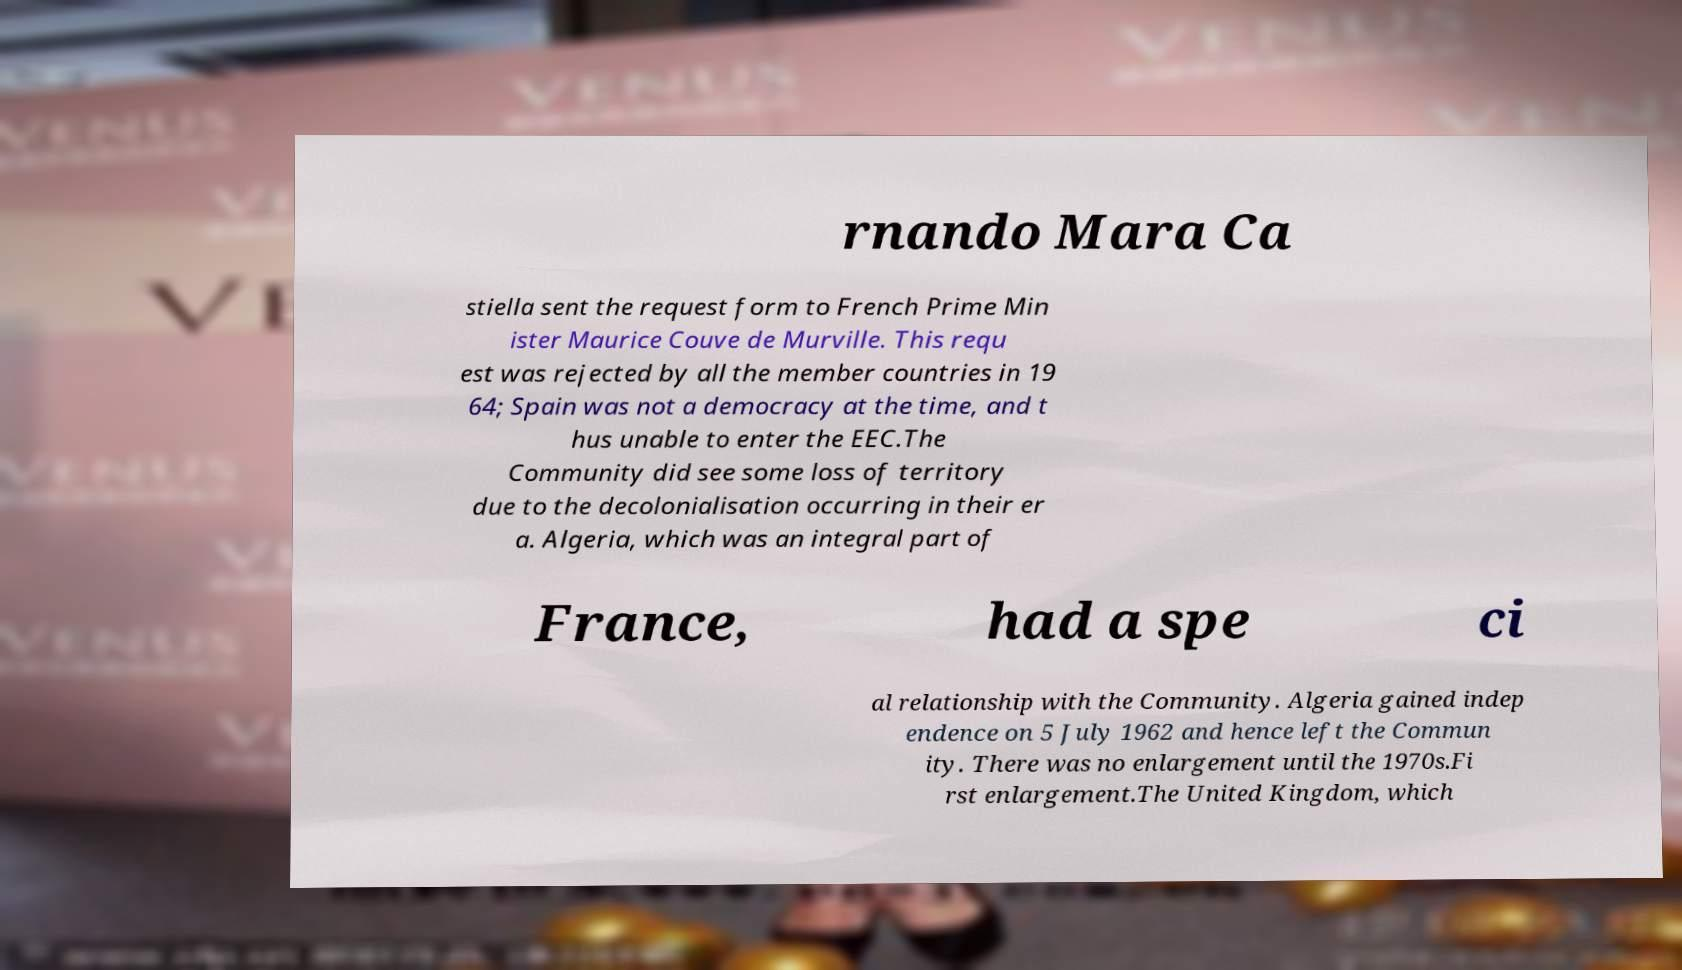Please read and relay the text visible in this image. What does it say? rnando Mara Ca stiella sent the request form to French Prime Min ister Maurice Couve de Murville. This requ est was rejected by all the member countries in 19 64; Spain was not a democracy at the time, and t hus unable to enter the EEC.The Community did see some loss of territory due to the decolonialisation occurring in their er a. Algeria, which was an integral part of France, had a spe ci al relationship with the Community. Algeria gained indep endence on 5 July 1962 and hence left the Commun ity. There was no enlargement until the 1970s.Fi rst enlargement.The United Kingdom, which 